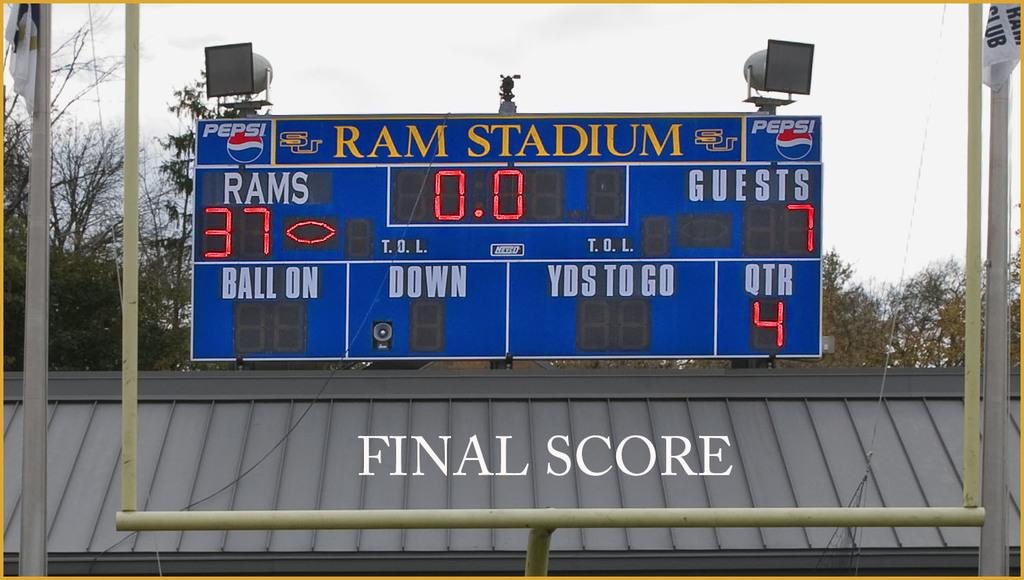<image>
Provide a brief description of the given image. A scoreboard for Ram Stadium with Final Score written below it. 